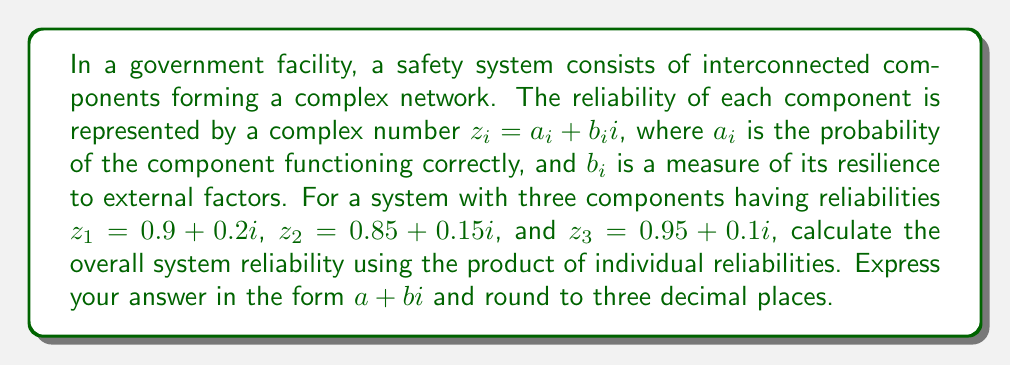Help me with this question. To evaluate the reliability of the safety system using complex network analysis, we need to multiply the complex numbers representing each component's reliability. This approach assumes that the components are connected in series, where the system fails if any component fails.

Let's follow these steps:

1) The overall reliability is given by the product of individual reliabilities:
   $$R = z_1 \cdot z_2 \cdot z_3$$

2) Multiply the first two complex numbers:
   $$(0.9 + 0.2i)(0.85 + 0.15i)$$
   $$ = (0.9 \cdot 0.85 - 0.2 \cdot 0.15) + (0.9 \cdot 0.15 + 0.2 \cdot 0.85)i$$
   $$ = 0.765 - 0.03 + (0.135 + 0.17)i$$
   $$ = 0.735 + 0.305i$$

3) Now multiply this result by the third complex number:
   $$(0.735 + 0.305i)(0.95 + 0.1i)$$
   $$ = (0.735 \cdot 0.95 - 0.305 \cdot 0.1) + (0.735 \cdot 0.1 + 0.305 \cdot 0.95)i$$
   $$ = 0.69825 - 0.0305 + (0.0735 + 0.28975)i$$
   $$ = 0.66775 + 0.36325i$$

4) Rounding to three decimal places:
   $$R \approx 0.668 + 0.363i$$

This complex number represents the overall reliability of the system, where the real part (0.668) is the probability of the entire system functioning correctly, and the imaginary part (0.363) represents the system's overall resilience to external factors.
Answer: $0.668 + 0.363i$ 